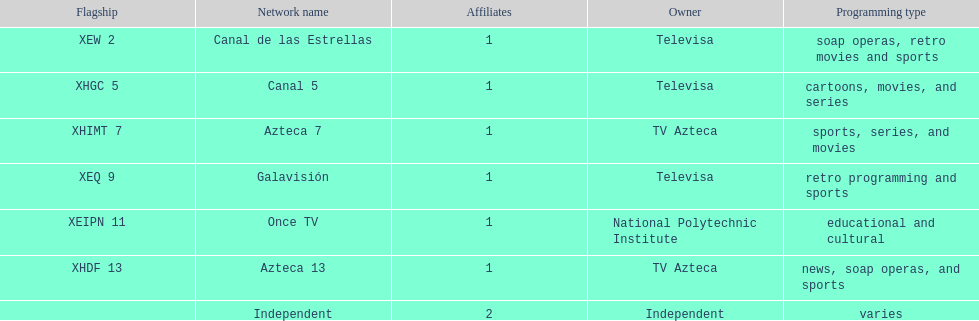How many networks does televisa own? 3. 